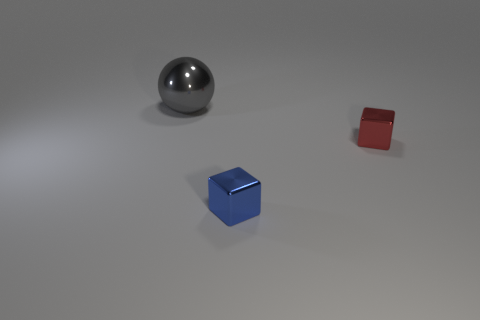Add 3 large gray objects. How many objects exist? 6 Subtract all cubes. How many objects are left? 1 Add 3 tiny blocks. How many tiny blocks exist? 5 Subtract 0 green cylinders. How many objects are left? 3 Subtract all big metallic things. Subtract all large yellow shiny things. How many objects are left? 2 Add 3 small red shiny things. How many small red shiny things are left? 4 